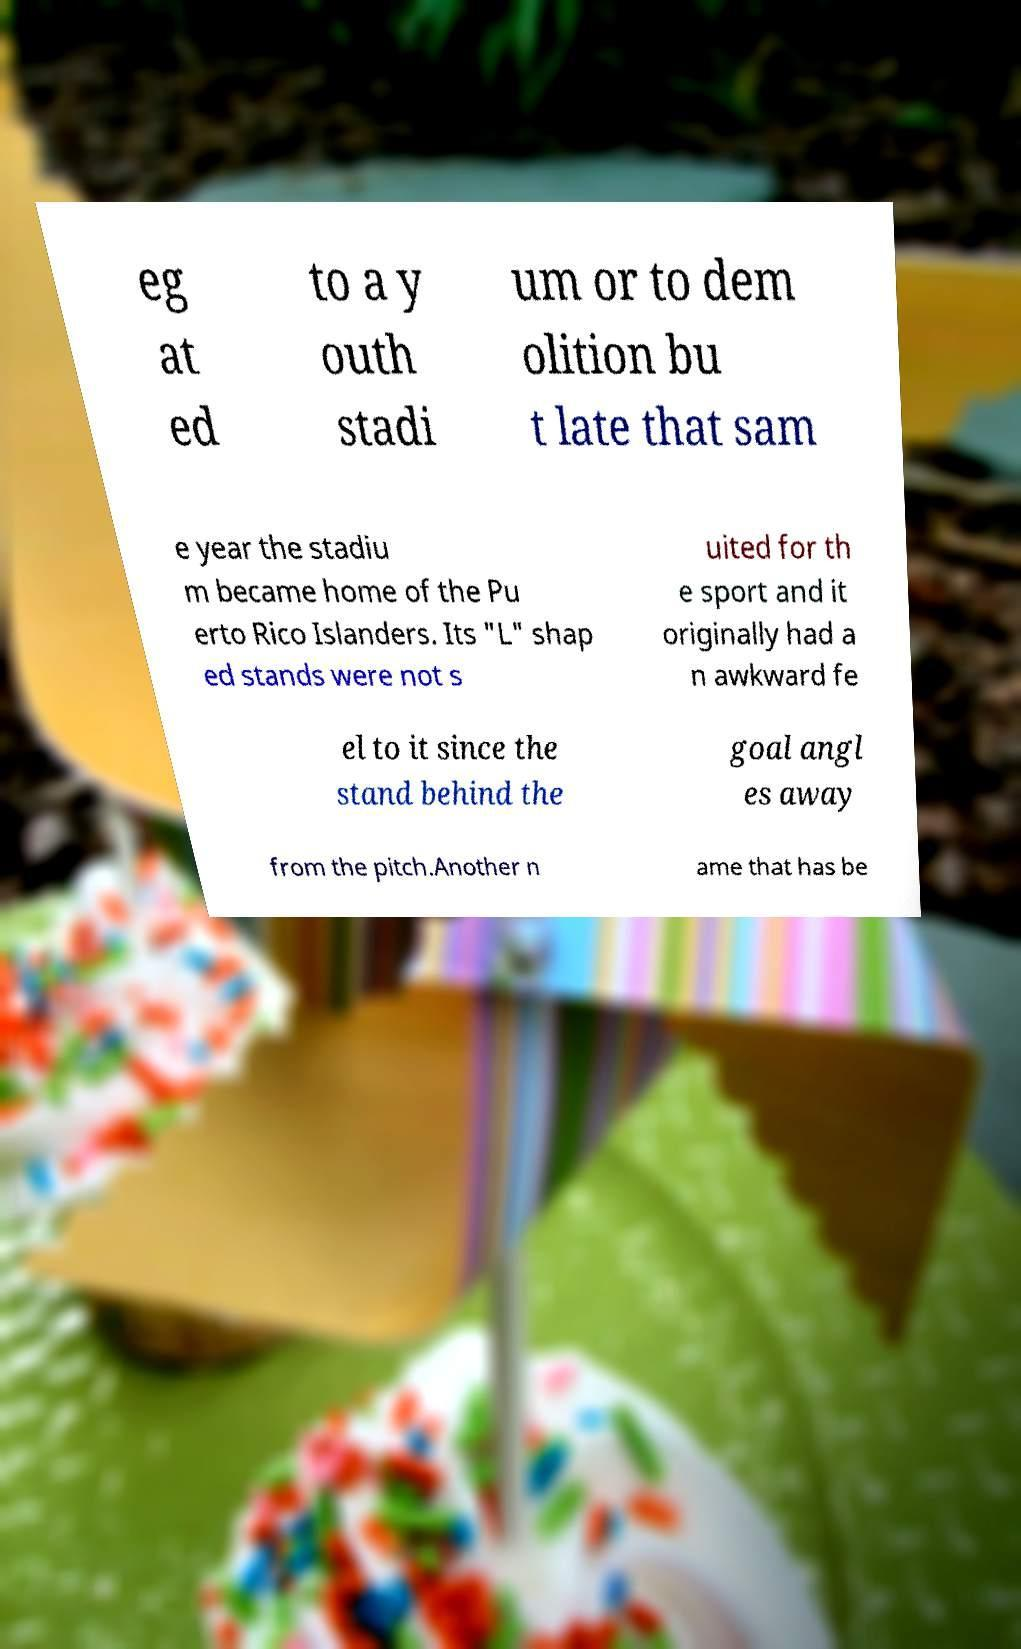Could you extract and type out the text from this image? eg at ed to a y outh stadi um or to dem olition bu t late that sam e year the stadiu m became home of the Pu erto Rico Islanders. Its "L" shap ed stands were not s uited for th e sport and it originally had a n awkward fe el to it since the stand behind the goal angl es away from the pitch.Another n ame that has be 